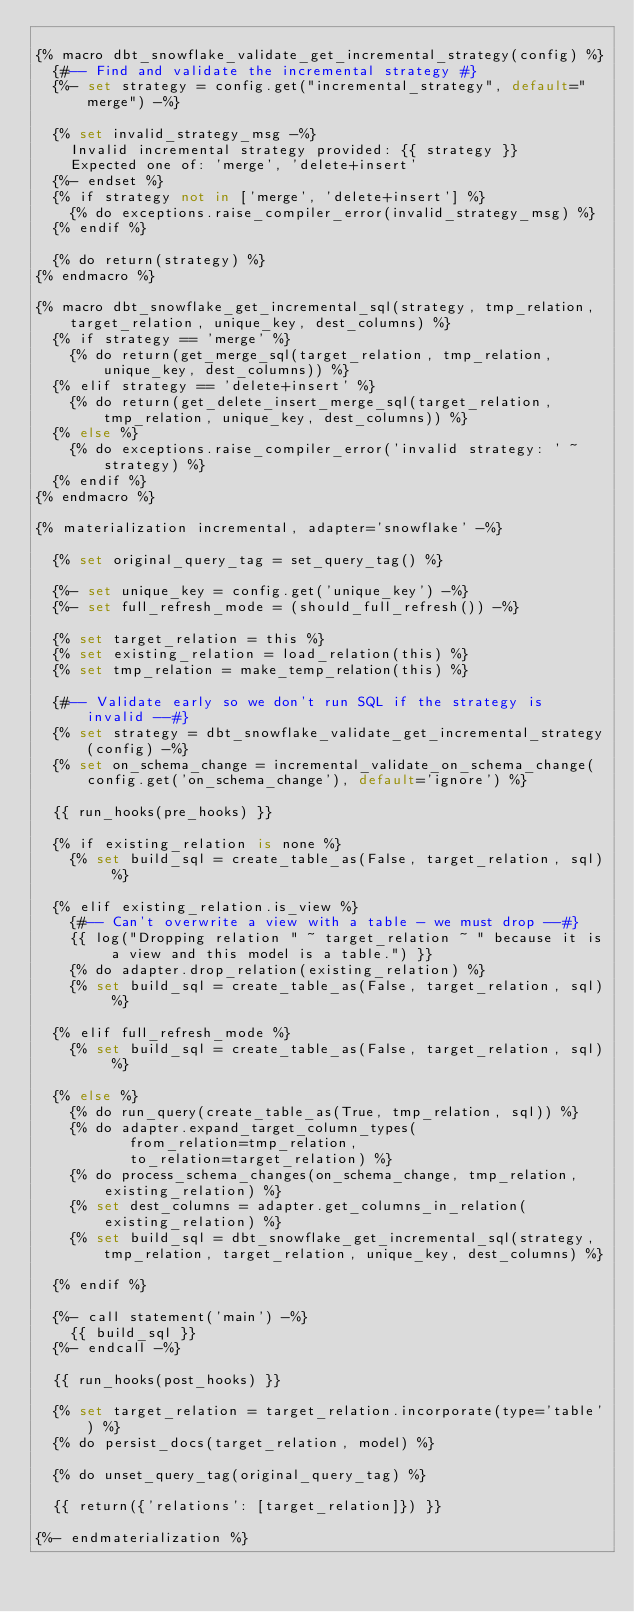<code> <loc_0><loc_0><loc_500><loc_500><_SQL_>
{% macro dbt_snowflake_validate_get_incremental_strategy(config) %}
  {#-- Find and validate the incremental strategy #}
  {%- set strategy = config.get("incremental_strategy", default="merge") -%}

  {% set invalid_strategy_msg -%}
    Invalid incremental strategy provided: {{ strategy }}
    Expected one of: 'merge', 'delete+insert'
  {%- endset %}
  {% if strategy not in ['merge', 'delete+insert'] %}
    {% do exceptions.raise_compiler_error(invalid_strategy_msg) %}
  {% endif %}

  {% do return(strategy) %}
{% endmacro %}

{% macro dbt_snowflake_get_incremental_sql(strategy, tmp_relation, target_relation, unique_key, dest_columns) %}
  {% if strategy == 'merge' %}
    {% do return(get_merge_sql(target_relation, tmp_relation, unique_key, dest_columns)) %}
  {% elif strategy == 'delete+insert' %}
    {% do return(get_delete_insert_merge_sql(target_relation, tmp_relation, unique_key, dest_columns)) %}
  {% else %}
    {% do exceptions.raise_compiler_error('invalid strategy: ' ~ strategy) %}
  {% endif %}
{% endmacro %}

{% materialization incremental, adapter='snowflake' -%}
   
  {% set original_query_tag = set_query_tag() %}

  {%- set unique_key = config.get('unique_key') -%}
  {%- set full_refresh_mode = (should_full_refresh()) -%}

  {% set target_relation = this %}
  {% set existing_relation = load_relation(this) %}
  {% set tmp_relation = make_temp_relation(this) %}

  {#-- Validate early so we don't run SQL if the strategy is invalid --#}
  {% set strategy = dbt_snowflake_validate_get_incremental_strategy(config) -%}
  {% set on_schema_change = incremental_validate_on_schema_change(config.get('on_schema_change'), default='ignore') %}

  {{ run_hooks(pre_hooks) }}

  {% if existing_relation is none %}
    {% set build_sql = create_table_as(False, target_relation, sql) %}
  
  {% elif existing_relation.is_view %}
    {#-- Can't overwrite a view with a table - we must drop --#}
    {{ log("Dropping relation " ~ target_relation ~ " because it is a view and this model is a table.") }}
    {% do adapter.drop_relation(existing_relation) %}
    {% set build_sql = create_table_as(False, target_relation, sql) %}
  
  {% elif full_refresh_mode %}
    {% set build_sql = create_table_as(False, target_relation, sql) %}
  
  {% else %}
    {% do run_query(create_table_as(True, tmp_relation, sql)) %}
    {% do adapter.expand_target_column_types(
           from_relation=tmp_relation,
           to_relation=target_relation) %}
    {% do process_schema_changes(on_schema_change, tmp_relation, existing_relation) %}
    {% set dest_columns = adapter.get_columns_in_relation(existing_relation) %}
    {% set build_sql = dbt_snowflake_get_incremental_sql(strategy, tmp_relation, target_relation, unique_key, dest_columns) %}
  
  {% endif %}

  {%- call statement('main') -%}
    {{ build_sql }}
  {%- endcall -%}

  {{ run_hooks(post_hooks) }}

  {% set target_relation = target_relation.incorporate(type='table') %}
  {% do persist_docs(target_relation, model) %}

  {% do unset_query_tag(original_query_tag) %}

  {{ return({'relations': [target_relation]}) }}

{%- endmaterialization %}</code> 